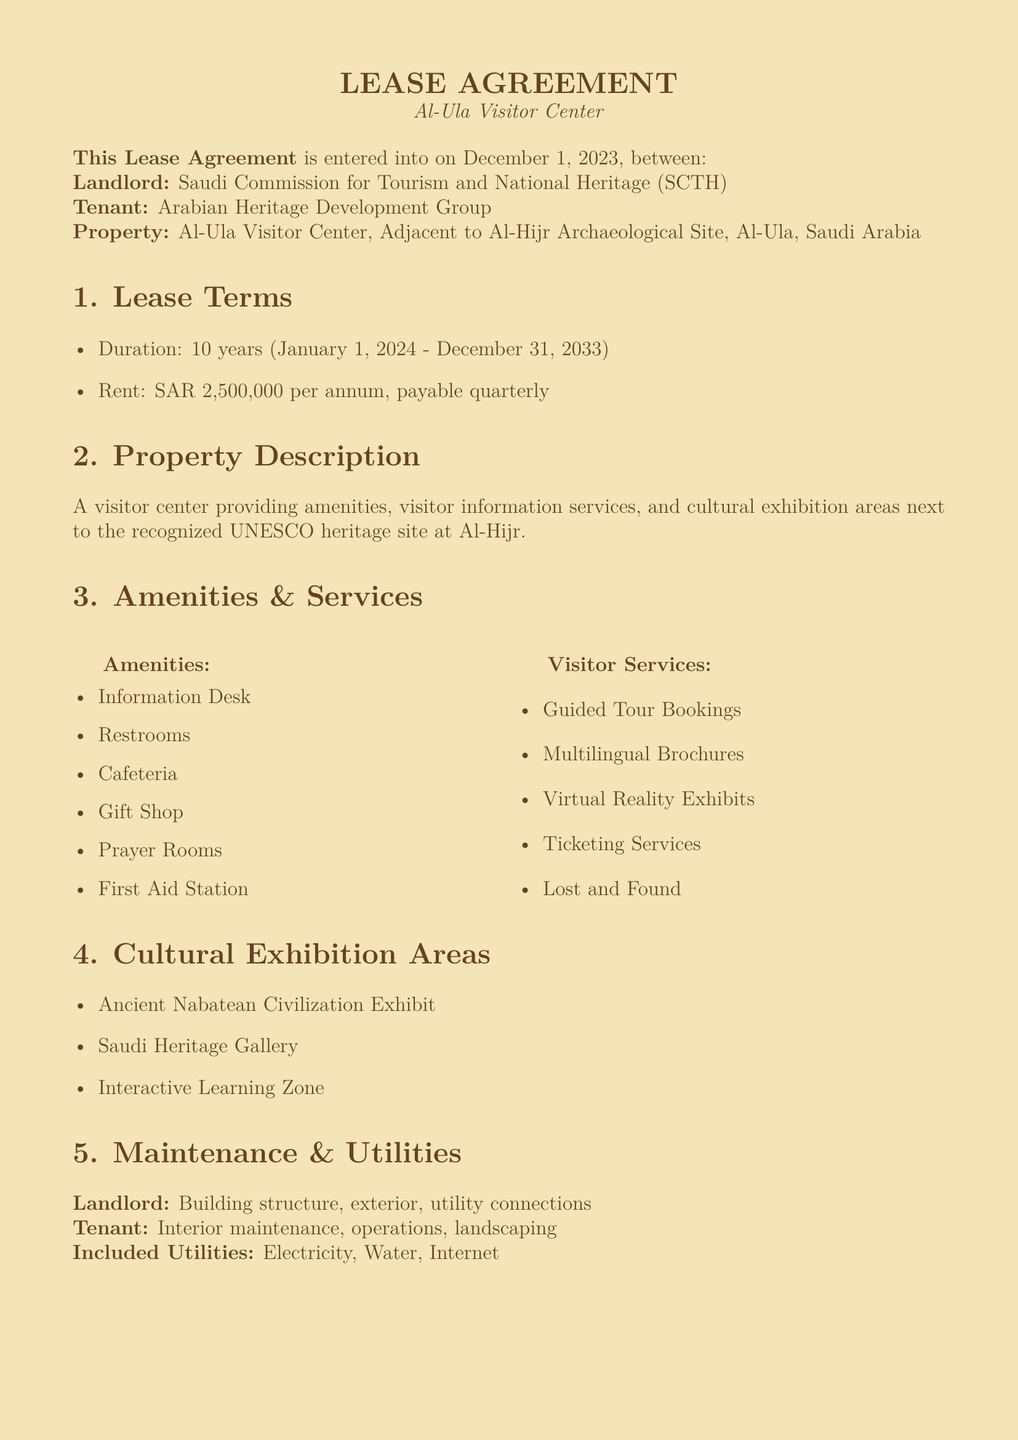What is the lease duration? The lease duration is specified in the lease terms section with a start and end date of January 1, 2024, to December 31, 2033.
Answer: 10 years Who is the landlord? The landlord is identified at the beginning of the lease agreement, stating the responsible party in the lease agreement.
Answer: Saudi Commission for Tourism and National Heritage What is the annual rent amount? The lease terms note the annual rent, which is explicitly mentioned in the document.
Answer: SAR 2,500,000 What types of services are offered at the visitor center? The amenities and visitor services sections list various services available to visitors, consolidating the overall visitor experience.
Answer: Guided Tour Bookings, Multilingual Brochures, Virtual Reality Exhibits, Ticketing Services, Lost and Found Which historical civilization is exhibited? The cultural exhibition areas mention specific civilizations and themes reflected in the exhibition area, highlighting the content focus.
Answer: Ancient Nabatean Civilization Exhibit What is included in the maintenance responsibilities of the landlord? The maintenance section outlines what falls under the landlord's responsibilities relating to the property upkeep and mutual obligations stipulated in the lease.
Answer: Building structure, exterior, utility connections What are the visitor information services provided? The visitor services explain the various support options available for guests, focusing on the informational aspect of the visitor center.
Answer: Multilingual Brochures What must the tenant adhere to regarding site conservation? The special conditions section emphasizes the mandatory considerations for preserving the heritage site's integrity, guiding tenant actions.
Answer: UNESCO guidelines What is the name of the tenant? The tenant is indicated in the introduction of the lease agreement, which also specifies their role concerning the property.
Answer: Arabian Heritage Development Group 